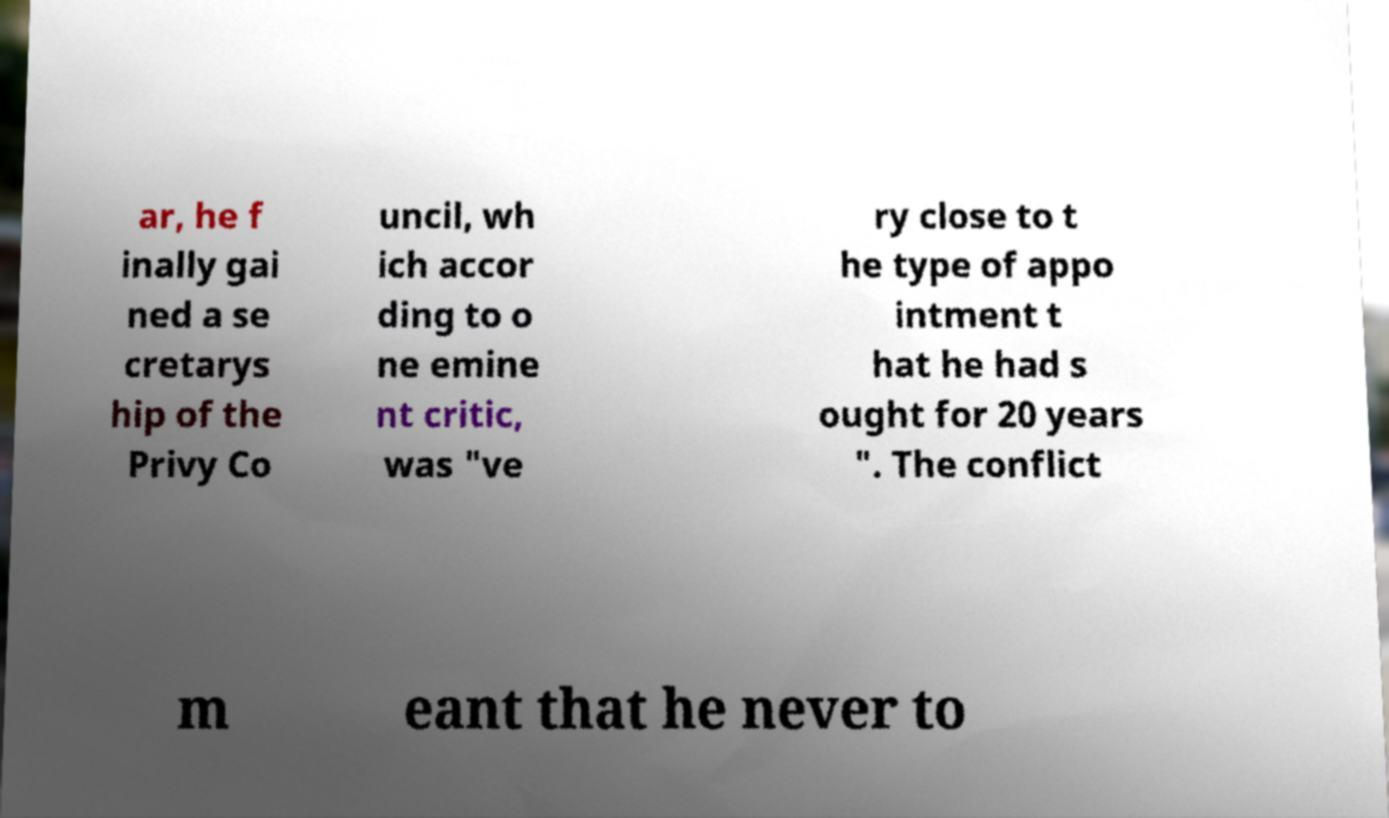Please read and relay the text visible in this image. What does it say? ar, he f inally gai ned a se cretarys hip of the Privy Co uncil, wh ich accor ding to o ne emine nt critic, was "ve ry close to t he type of appo intment t hat he had s ought for 20 years ". The conflict m eant that he never to 